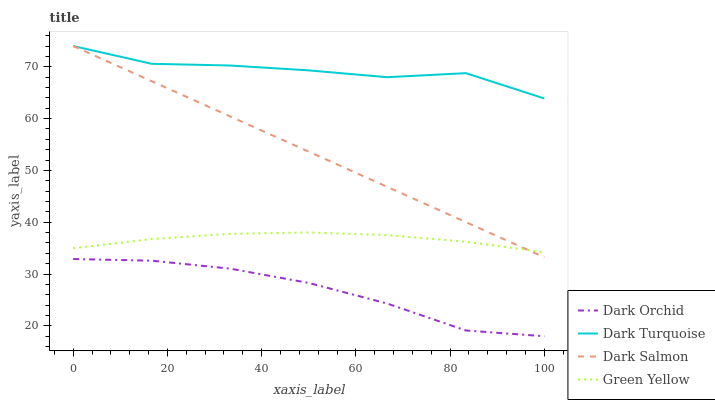Does Dark Orchid have the minimum area under the curve?
Answer yes or no. Yes. Does Dark Turquoise have the maximum area under the curve?
Answer yes or no. Yes. Does Green Yellow have the minimum area under the curve?
Answer yes or no. No. Does Green Yellow have the maximum area under the curve?
Answer yes or no. No. Is Dark Salmon the smoothest?
Answer yes or no. Yes. Is Dark Turquoise the roughest?
Answer yes or no. Yes. Is Green Yellow the smoothest?
Answer yes or no. No. Is Green Yellow the roughest?
Answer yes or no. No. Does Green Yellow have the lowest value?
Answer yes or no. No. Does Green Yellow have the highest value?
Answer yes or no. No. Is Dark Orchid less than Dark Turquoise?
Answer yes or no. Yes. Is Dark Turquoise greater than Green Yellow?
Answer yes or no. Yes. Does Dark Orchid intersect Dark Turquoise?
Answer yes or no. No. 